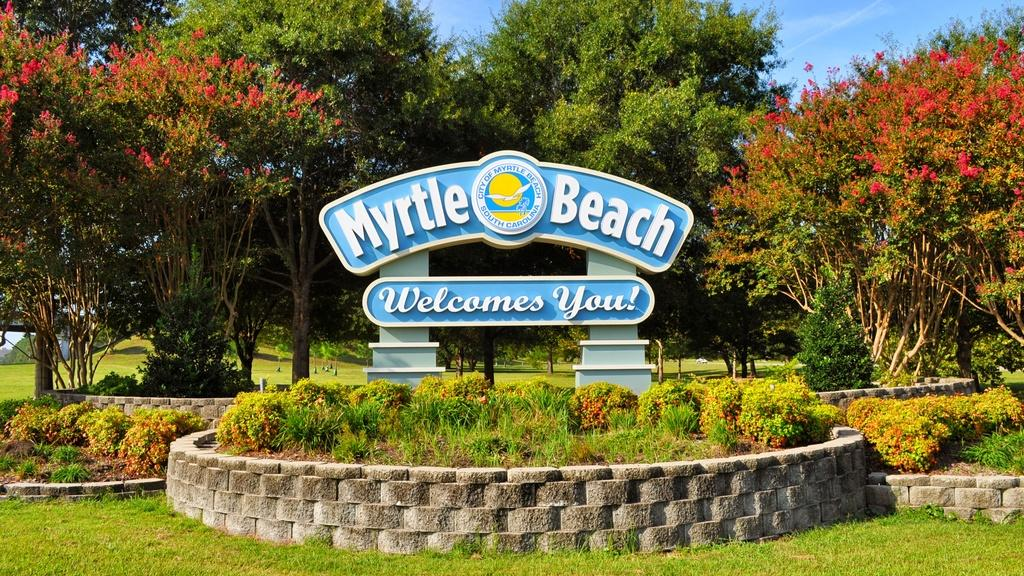What is the main object in the image? There is a name board in the image. What type of natural elements can be seen in the image? There are trees and garden plants visible in the image. What type of ground cover is present in the image? Grass is visible in the image. What type of structures are in the image? Small walls are present in the image. What is visible in the background of the image? The sky is visible in the image. What type of cracker is being served in the image? There is no cracker present in the image; it features a name board, trees, garden plants, grass, small walls, and the sky. Can you tell me how many people are holding soup bowls in the image? There are no people or soup bowls present in the image. 